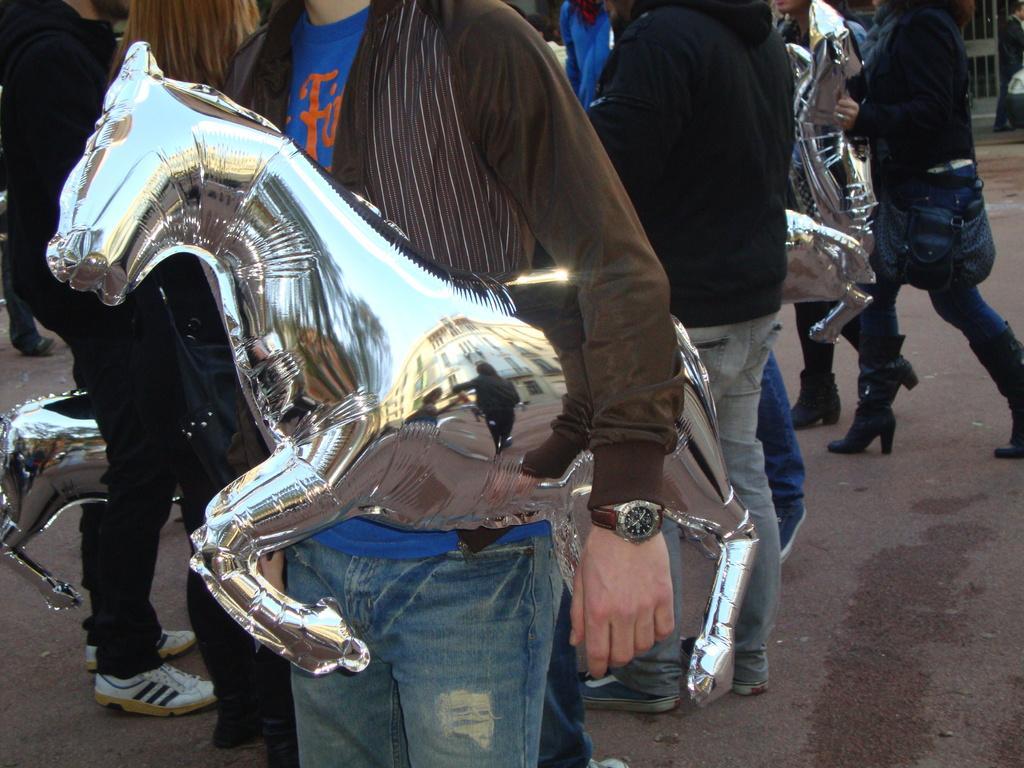How would you summarize this image in a sentence or two? In this picture we can see people and toys. This is a road. 